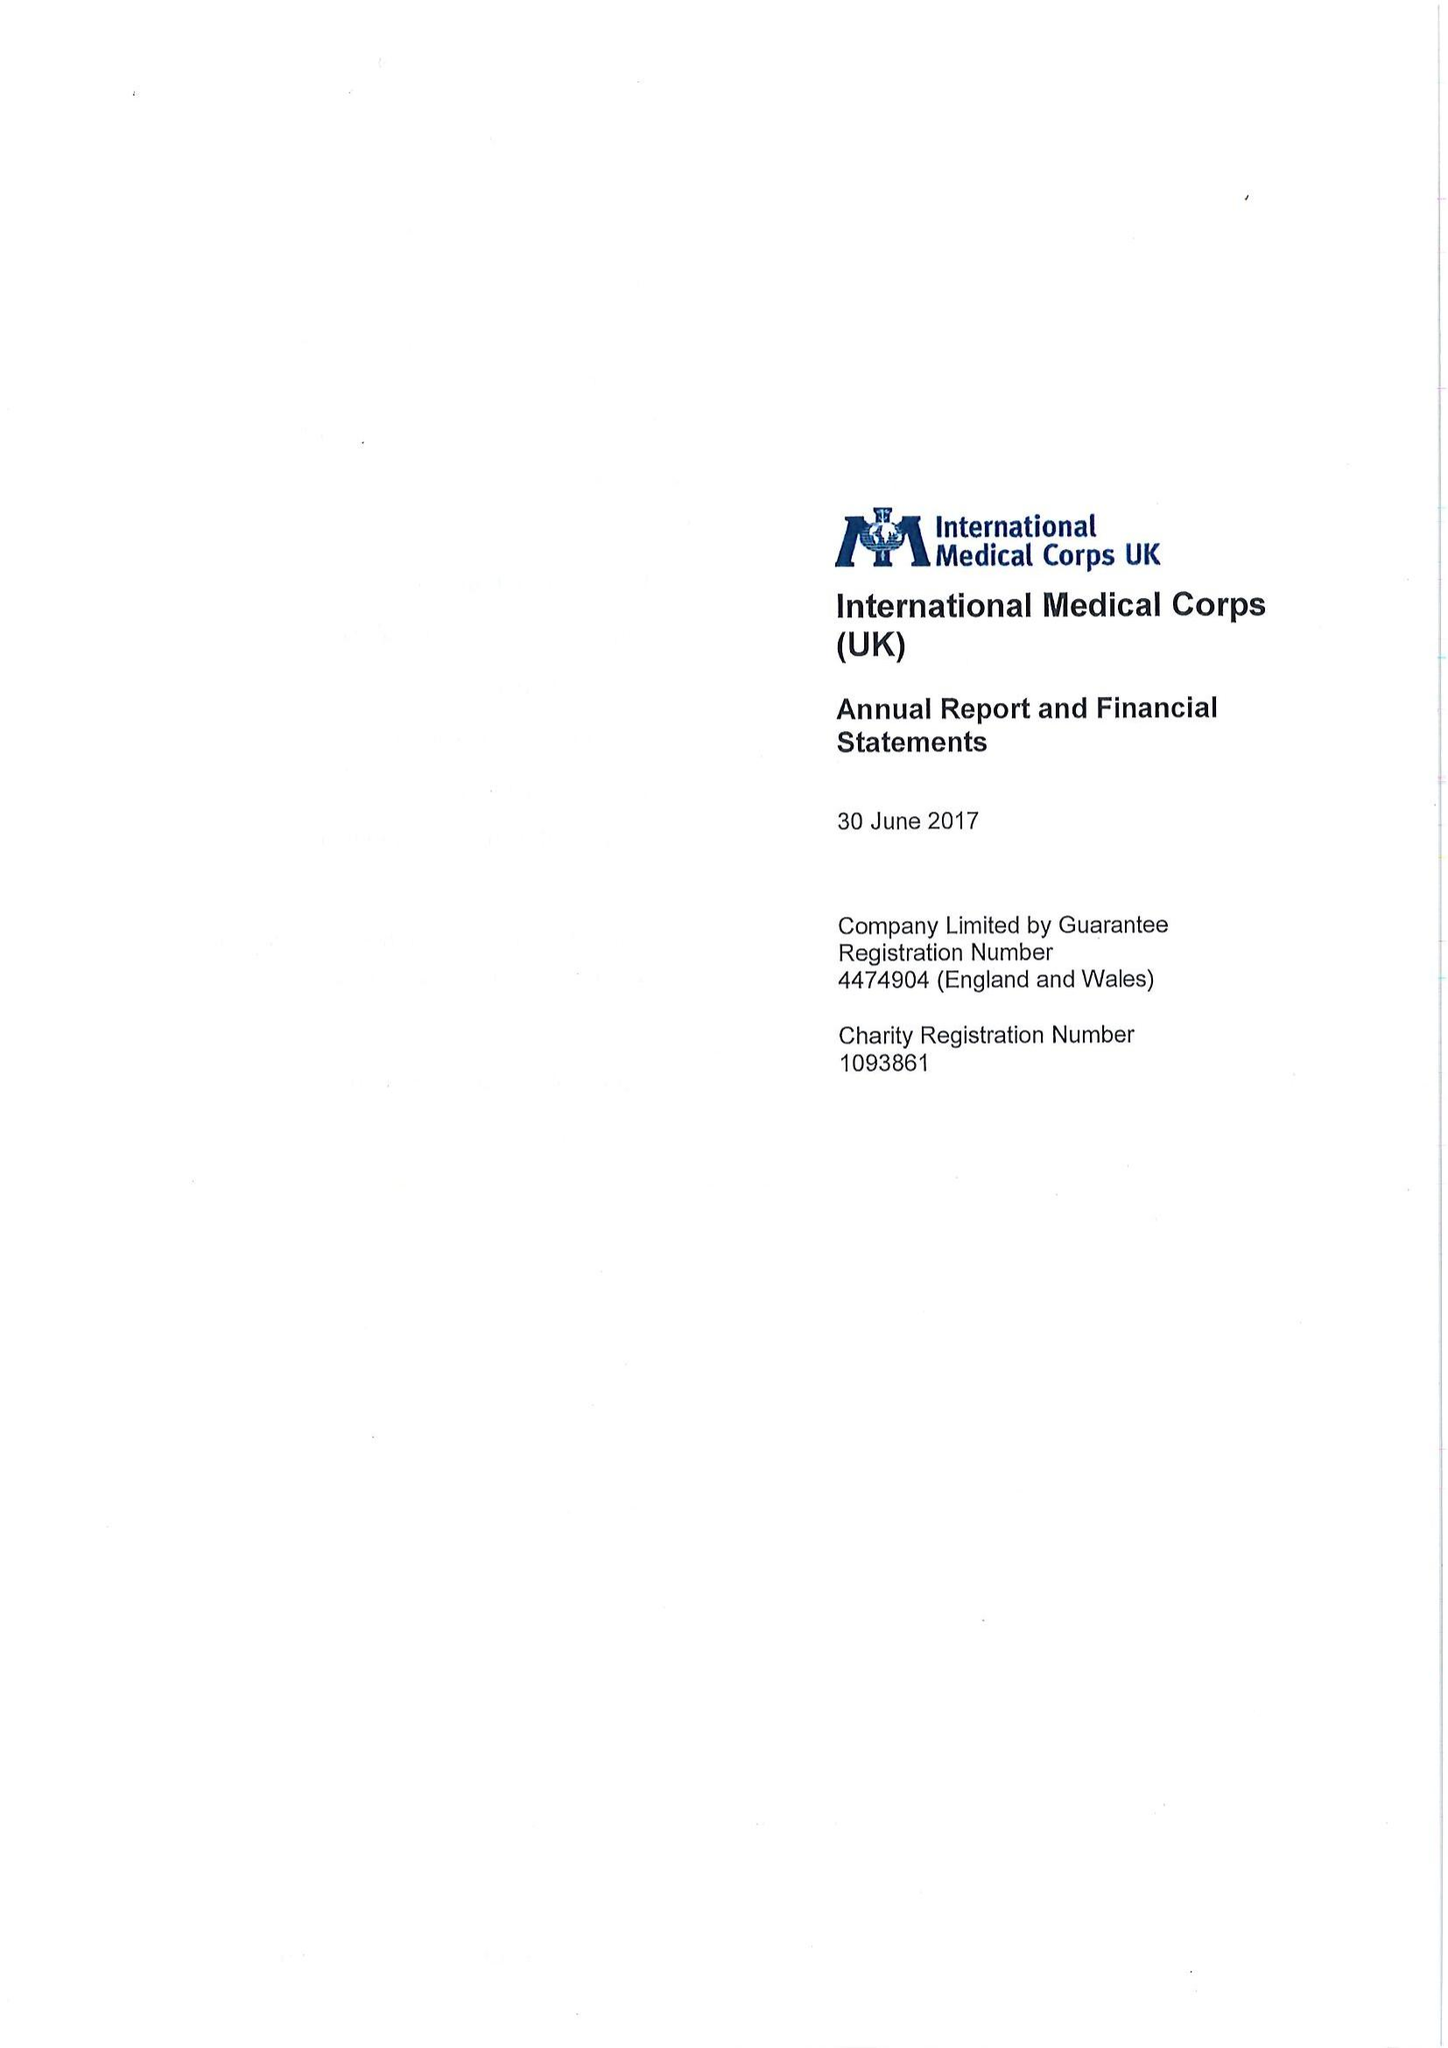What is the value for the spending_annually_in_british_pounds?
Answer the question using a single word or phrase. 128387295.00 